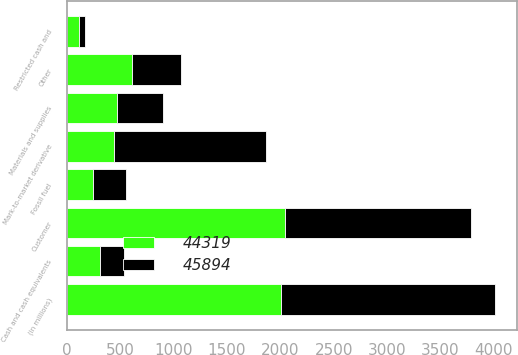<chart> <loc_0><loc_0><loc_500><loc_500><stacked_bar_chart><ecel><fcel>(in millions)<fcel>Cash and cash equivalents<fcel>Restricted cash and<fcel>Customer<fcel>Other<fcel>Mark-to-market derivative<fcel>Fossil fuel<fcel>Materials and supplies<nl><fcel>44319<fcel>2007<fcel>311<fcel>118<fcel>2041<fcel>611<fcel>445<fcel>252<fcel>471<nl><fcel>45894<fcel>2006<fcel>224<fcel>58<fcel>1747<fcel>462<fcel>1418<fcel>300<fcel>431<nl></chart> 